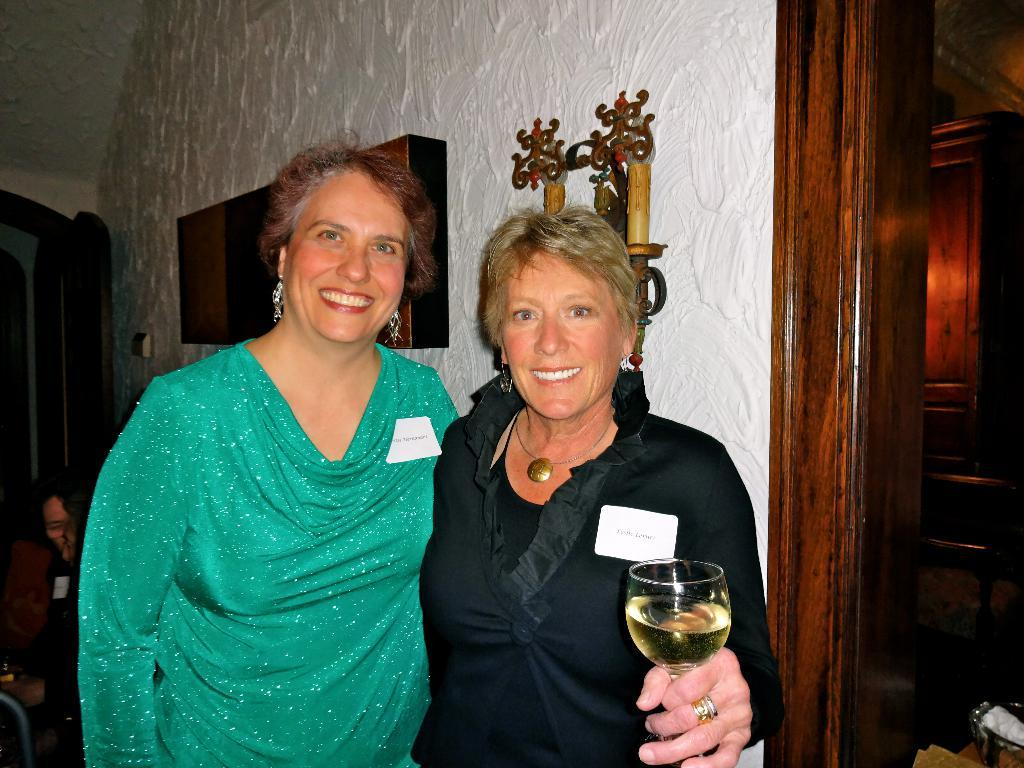How many people are in the image? There are three people in the image: two men and one woman. What are the men doing in the image? The men are standing in the image. What is the woman holding in her hand? The woman is holding a wine glass in her hand. What grade did the woman receive on her recent exam in the image? There is no information about an exam or a grade in the image. 